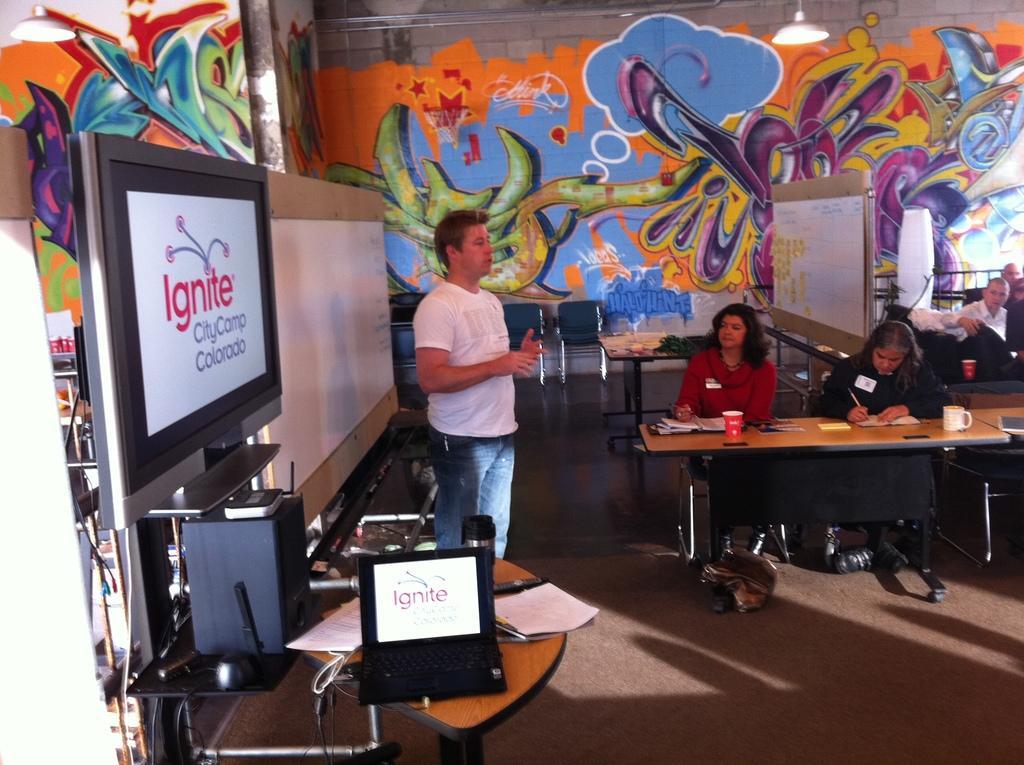In one or two sentences, can you explain what this image depicts? This image is taken inside a room. There are few people in this room. In the middle of the image a man standing and talking. In the left side of the image there is a screen with text on it, speaker box, laptop and few papers on the table. In the right side of the image few people are sitting on the chairs and there is a table with few things on it. In the background there is a wall with graffiti on it. At the top of the image there is a light. 